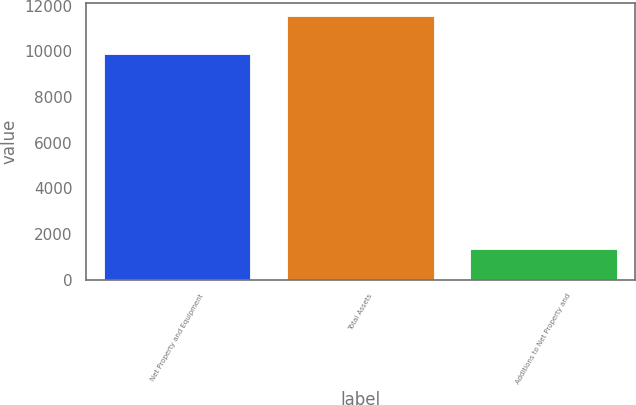Convert chart to OTSL. <chart><loc_0><loc_0><loc_500><loc_500><bar_chart><fcel>Net Property and Equipment<fcel>Total Assets<fcel>Additions to Net Property and<nl><fcel>9859<fcel>11526<fcel>1342<nl></chart> 